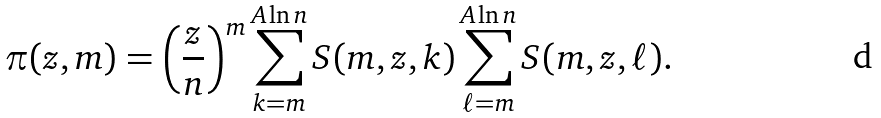<formula> <loc_0><loc_0><loc_500><loc_500>\pi ( z , m ) = \left ( \frac { z } { n } \right ) ^ { m } \sum _ { k = m } ^ { A \ln n } S ( m , z , k ) \sum _ { \ell = m } ^ { A \ln n } S ( m , z , \ell ) .</formula> 